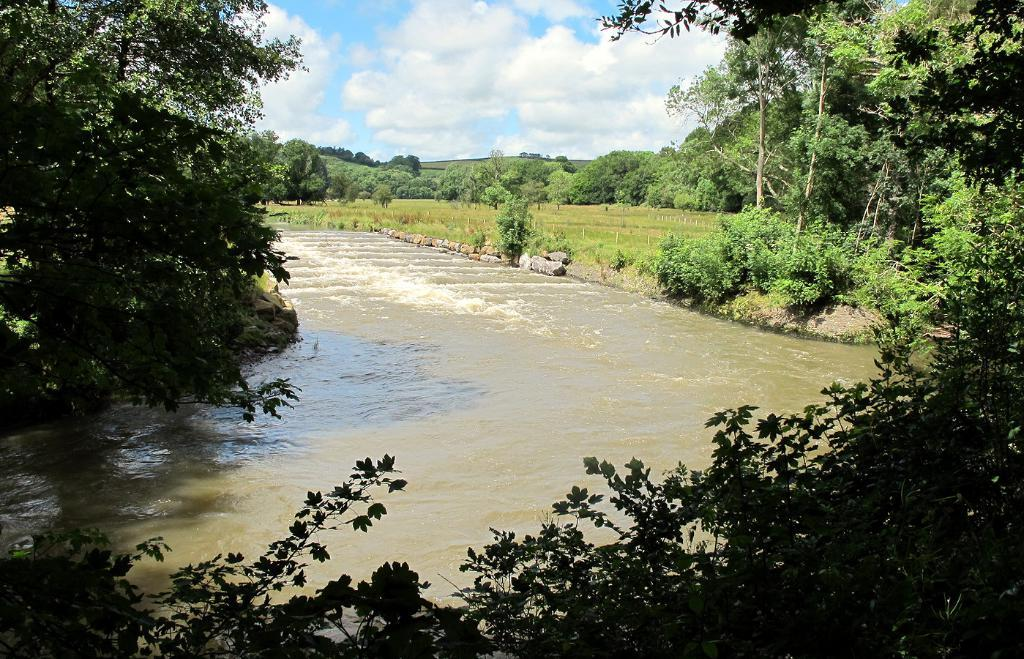What is flowing in the middle of the image? There is water flowing in the middle of the image. What type of vegetation is present on either side of the image? There are trees on either side of the image. What is visible at the top of the image? The sky is visible at the top of the image. Where is the horn located in the image? There is no horn present in the image. What type of shirt is hanging from the tree on the left side of the image? There is no shirt present in the image; only trees and water are visible. 